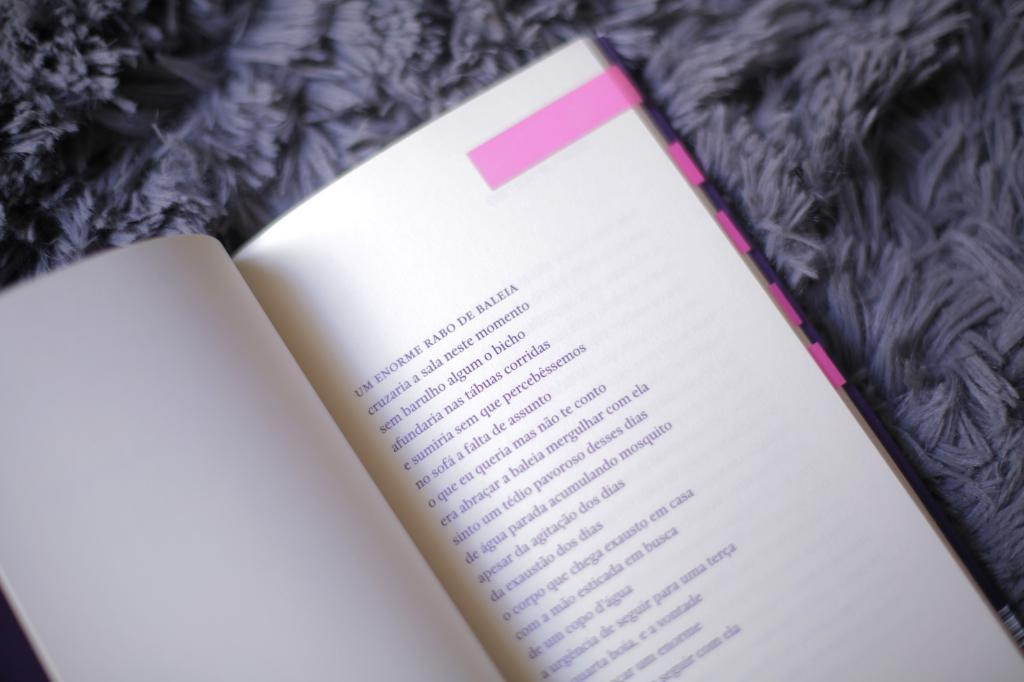<image>
Give a short and clear explanation of the subsequent image. A book with several pink flags is open to a page where the text begins Um Enorme. 